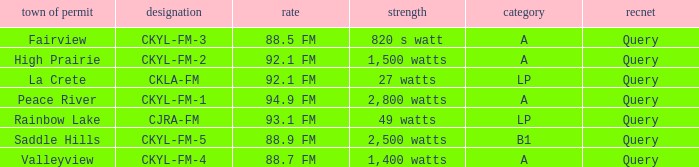Which city of license possesses a power capacity of 1,400 watts? Valleyview. 